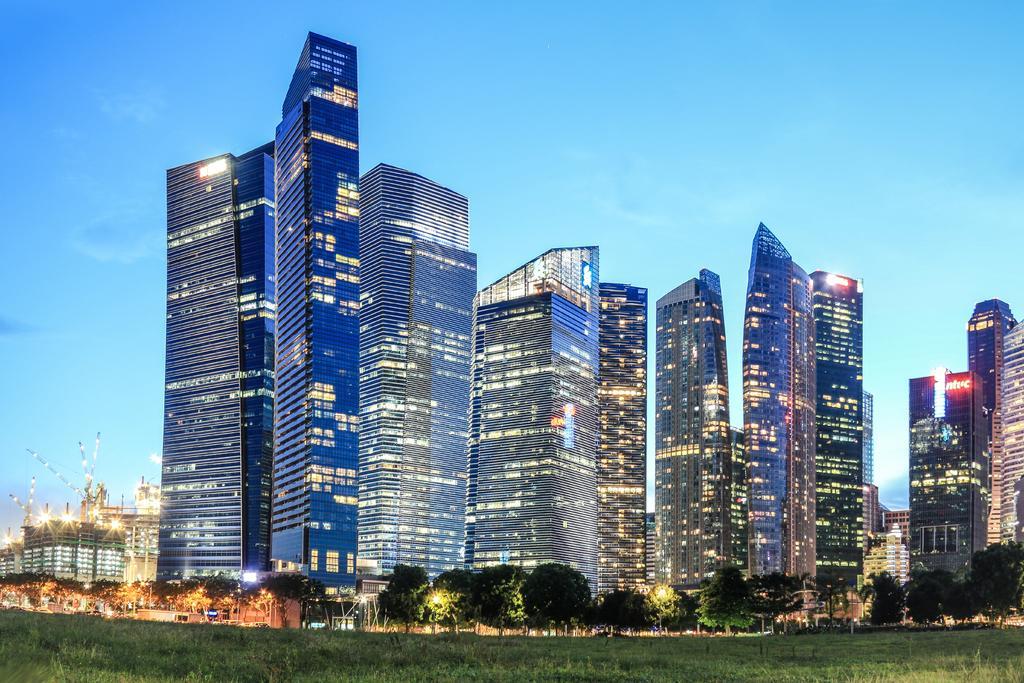Could you give a brief overview of what you see in this image? The pictures captured in the evening time,there are beautiful tall towers with a lot of lights and in front of the buildings there are some trees and grass. 